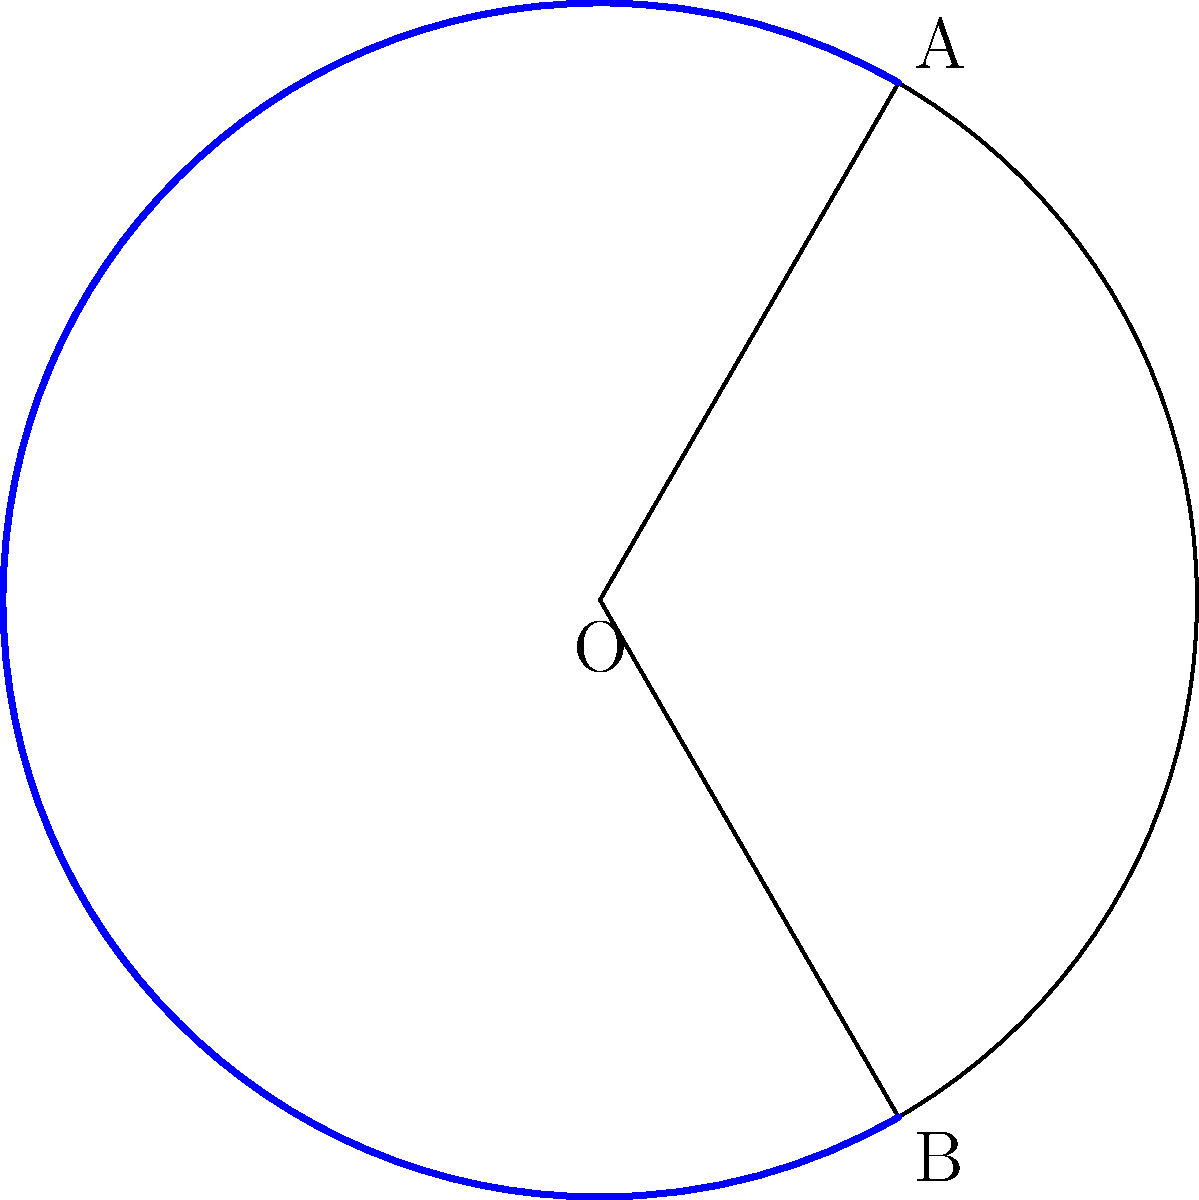As a successful musician, you're planning a special fan section in your upcoming arena concert. The circular stage has a radius of 15 meters, and you want to allocate a 120° circular segment for VIP fans. Calculate the area of this VIP section to determine how many fans can be accommodated. Round your answer to the nearest square meter. To solve this problem, we need to calculate the area of a circular segment. The formula for the area of a circular segment is:

$$A = \frac{r^2}{2}(\theta - \sin\theta)$$

Where:
$A$ is the area of the segment
$r$ is the radius of the circle
$\theta$ is the central angle in radians

Step 1: Convert the angle from degrees to radians
$$\theta = 120° \times \frac{\pi}{180°} = \frac{2\pi}{3} \approx 2.0944 \text{ radians}$$

Step 2: Calculate $\sin\theta$
$$\sin\theta = \sin(\frac{2\pi}{3}) = \frac{\sqrt{3}}{2} \approx 0.8660$$

Step 3: Apply the formula
$$A = \frac{15^2}{2}(\frac{2\pi}{3} - \frac{\sqrt{3}}{2})$$
$$A = \frac{225}{2}(2.0944 - 0.8660)$$
$$A = 112.5(1.2284)$$
$$A = 138.195 \text{ m}^2$$

Step 4: Round to the nearest square meter
$$A \approx 138 \text{ m}^2$$
Answer: 138 m² 